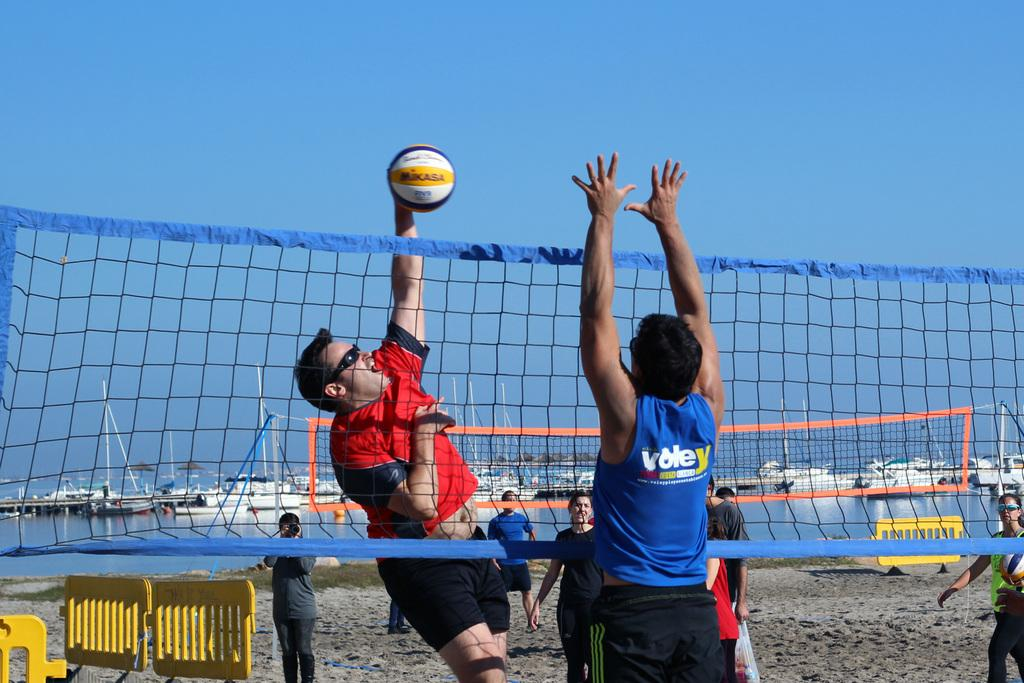What are the people in the image doing? The people are playing volleyball in the image. Where is the volleyball game taking place? The volleyball game is taking place on the sea shore. What can be seen in the water behind the group of people? Ships are visible in the water behind the group of people. How many potatoes are being used as a volleyball in the image? There are no potatoes being used as a volleyball in the image; a regular volleyball is being used. What type of bomb can be seen in the image? There is no bomb present in the image; it features a group of people playing volleyball on the sea shore. 